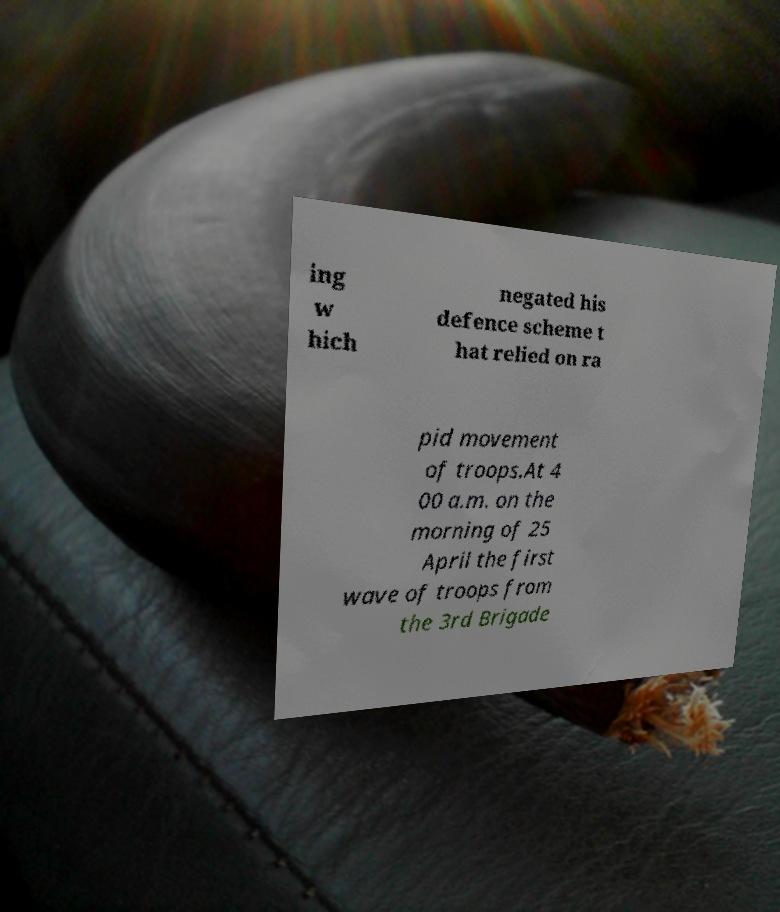Can you accurately transcribe the text from the provided image for me? ing w hich negated his defence scheme t hat relied on ra pid movement of troops.At 4 00 a.m. on the morning of 25 April the first wave of troops from the 3rd Brigade 